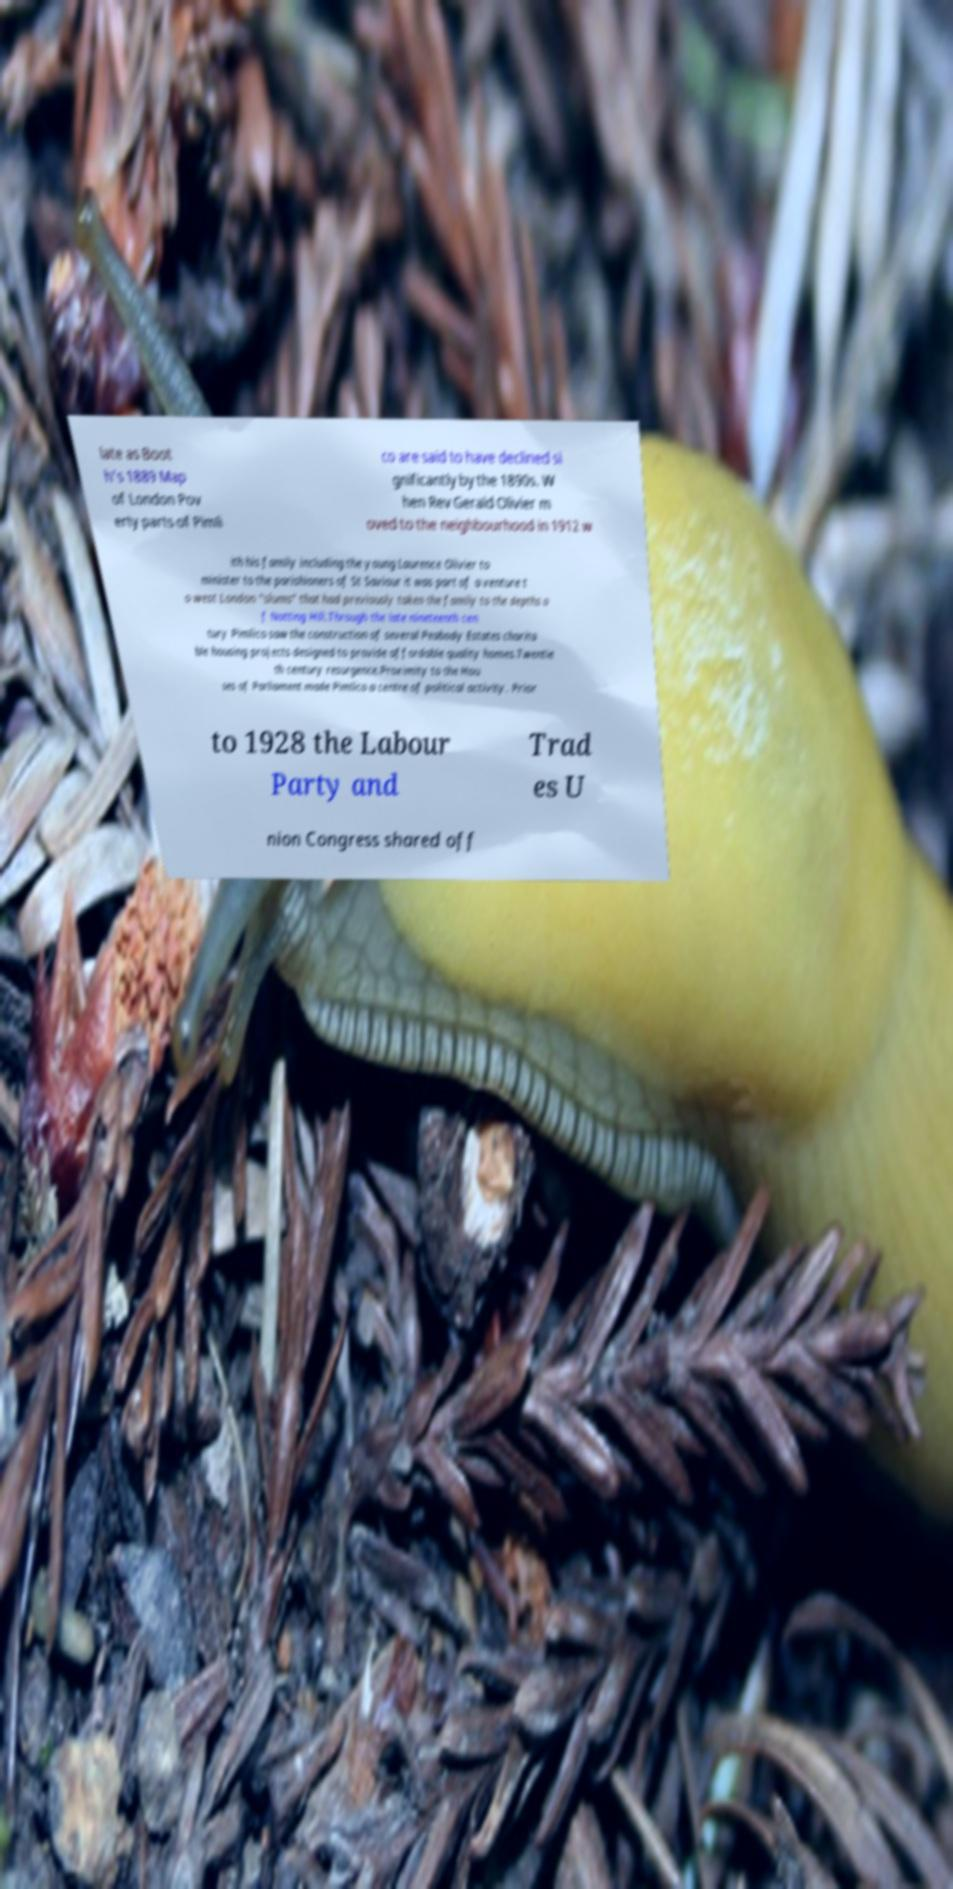Please identify and transcribe the text found in this image. late as Boot h's 1889 Map of London Pov erty parts of Pimli co are said to have declined si gnificantly by the 1890s. W hen Rev Gerald Olivier m oved to the neighbourhood in 1912 w ith his family including the young Laurence Olivier to minister to the parishioners of St Saviour it was part of a venture t o west London "slums" that had previously taken the family to the depths o f Notting Hill.Through the late nineteenth cen tury Pimlico saw the construction of several Peabody Estates charita ble housing projects designed to provide affordable quality homes.Twentie th century resurgence.Proximity to the Hou ses of Parliament made Pimlico a centre of political activity. Prior to 1928 the Labour Party and Trad es U nion Congress shared off 